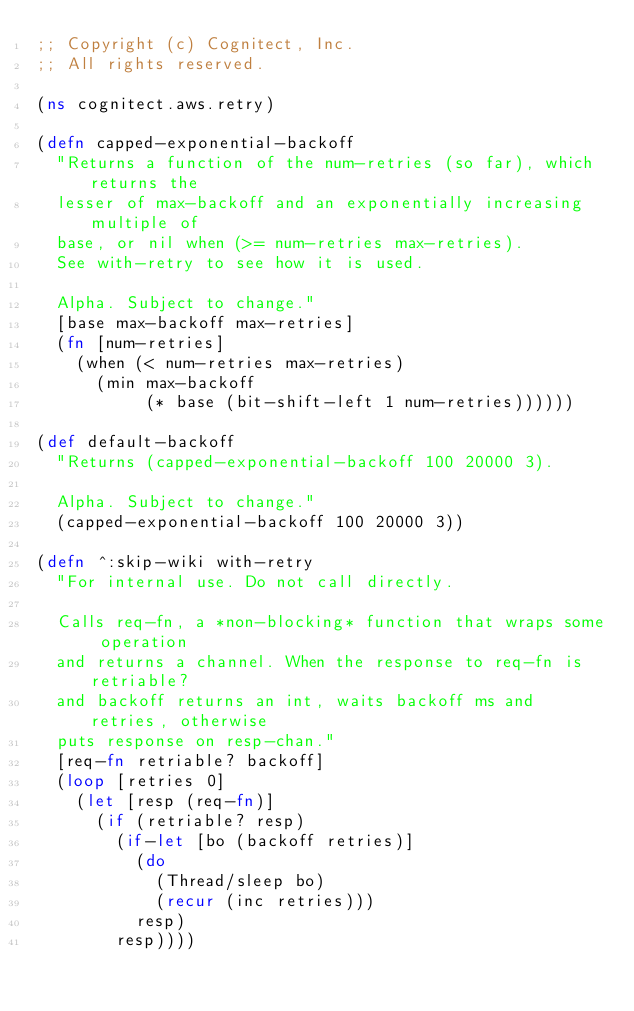<code> <loc_0><loc_0><loc_500><loc_500><_Clojure_>;; Copyright (c) Cognitect, Inc.
;; All rights reserved.

(ns cognitect.aws.retry)

(defn capped-exponential-backoff
  "Returns a function of the num-retries (so far), which returns the
  lesser of max-backoff and an exponentially increasing multiple of
  base, or nil when (>= num-retries max-retries).
  See with-retry to see how it is used.

  Alpha. Subject to change."
  [base max-backoff max-retries]
  (fn [num-retries]
    (when (< num-retries max-retries)
      (min max-backoff
           (* base (bit-shift-left 1 num-retries))))))

(def default-backoff
  "Returns (capped-exponential-backoff 100 20000 3).

  Alpha. Subject to change."
  (capped-exponential-backoff 100 20000 3))

(defn ^:skip-wiki with-retry
  "For internal use. Do not call directly.

  Calls req-fn, a *non-blocking* function that wraps some operation
  and returns a channel. When the response to req-fn is retriable?
  and backoff returns an int, waits backoff ms and retries, otherwise
  puts response on resp-chan."
  [req-fn retriable? backoff]
  (loop [retries 0]
    (let [resp (req-fn)]
      (if (retriable? resp)
        (if-let [bo (backoff retries)]
          (do
            (Thread/sleep bo)
            (recur (inc retries)))
          resp)
        resp))))
</code> 